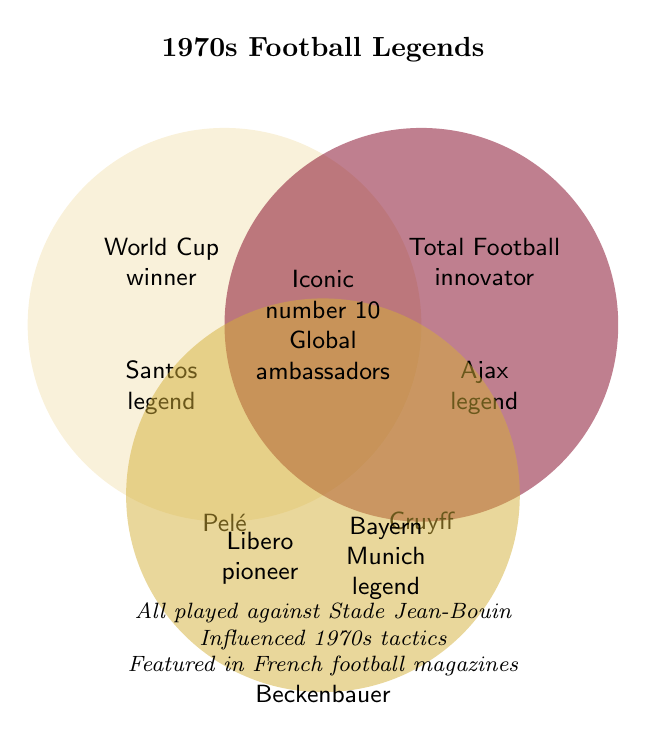Who is known for Total Football innovation? Look inside the circle labeled 'Cruyff' and locate the text. Johan Cruyff is attributed as the 'Total Football innovator'.
Answer: Cruyff Which legend is associated with Santos? Identify the section specific to Pelé. The text 'Santos legend' is listed within his circle.
Answer: Pelé Where in the Venn diagram can you find 'Iconic number 10'? Notice the central overlapping area where all three circles intersect. The text 'Iconic number 10' is displayed there.
Answer: In the center How are Beckenbauer and Cruyff connected in the Venn diagram? Explore the middle of each individual circle. They overlap in the area labeled 'Iconic number 10' and 'Global ambassadors', indicating they share these traits.
Answer: Iconic number 10, Global ambassadors Which football legends are described as 'Global football ambassadors'? Examine the center of the Venn diagram where all circles meet. All three legends, Pelé, Cruyff, and Beckenbauer, are described as 'Global football ambassadors'.
Answer: Pelé, Cruyff, Beckenbauer Who is referenced as the 'Libero pioneer'? Look for the intersection belonging to Beckenbauer. The exclusive text 'Libero pioneer' identifies him.
Answer: Beckenbauer What common attributes do all three legends share? The attributes listed in the central part of the figure pertain to all three. They include 'Iconic number 10', 'Global football ambassadors', 'Played against Stade Jean-Bouin', 'Influenced 1970s tactics', and 'Featured in French football magazines'.
Answer: Multiple common attributes Which individuals played against Stade Jean-Bouin? The text at the bottom states all legends played against Stade Jean-Bouin. Since this applies globally, each circle inherently includes this.
Answer: All three legends Who among the three influenced 1970s football tactics? Similar to playing against Stade Jean-Bouin, the text at the bottom indicates all three legends impacted 1970s football tactics.
Answer: All three legends Are there more shared or unique characteristics in the Venn diagram? Evaluate the quantity of shared traits (central and intersecting areas) versus unique traits (individual circle areas). There are slightly more unique details than shared.
Answer: Unique characteristics 